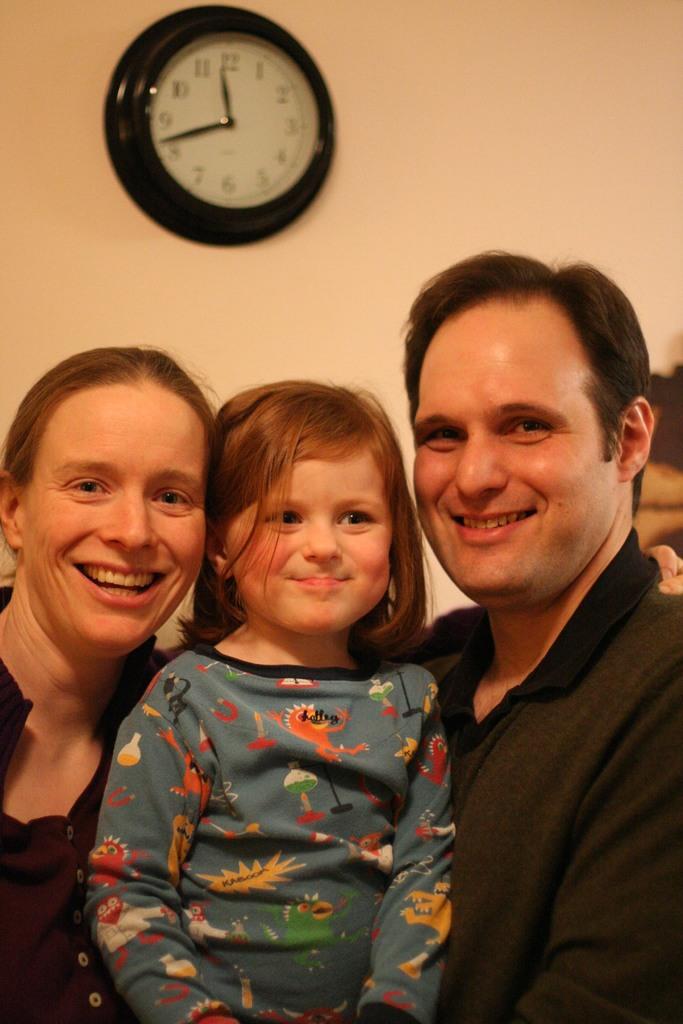What time does the clock say it is?
Your answer should be compact. 11:42. What number is the big hand closest to?
Offer a terse response. 8. 